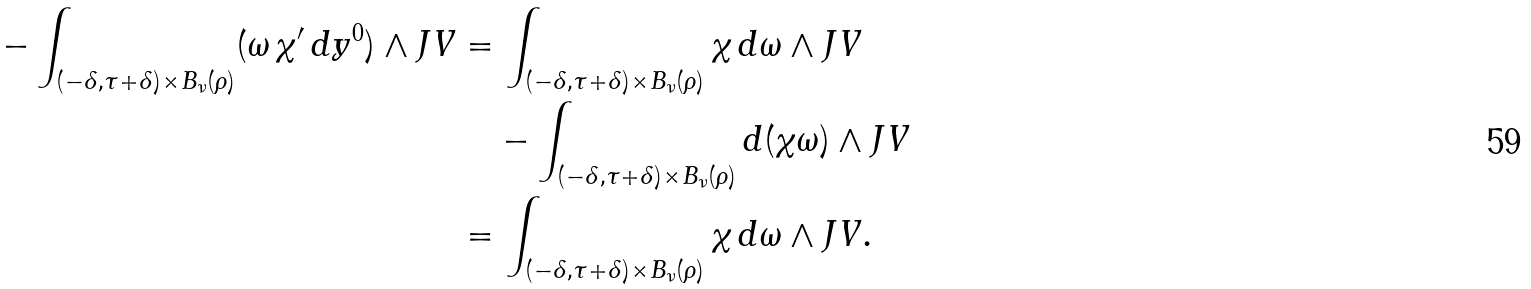<formula> <loc_0><loc_0><loc_500><loc_500>- \int _ { ( - \delta , \tau + \delta ) \times { B _ { \nu } ( \rho ) } } ( \omega \, \chi ^ { \prime } \, d y ^ { 0 } ) \wedge { J } V & = \int _ { ( - \delta , \tau + \delta ) \times { B _ { \nu } ( \rho ) } } \chi \, d \omega \wedge { J } V \\ & \quad - \int _ { ( - \delta , \tau + \delta ) \times { B _ { \nu } ( \rho ) } } d ( \chi \omega ) \wedge { J } V \\ & = \int _ { ( - \delta , \tau + \delta ) \times { B _ { \nu } ( \rho ) } } \chi \, d \omega \wedge { J } V .</formula> 